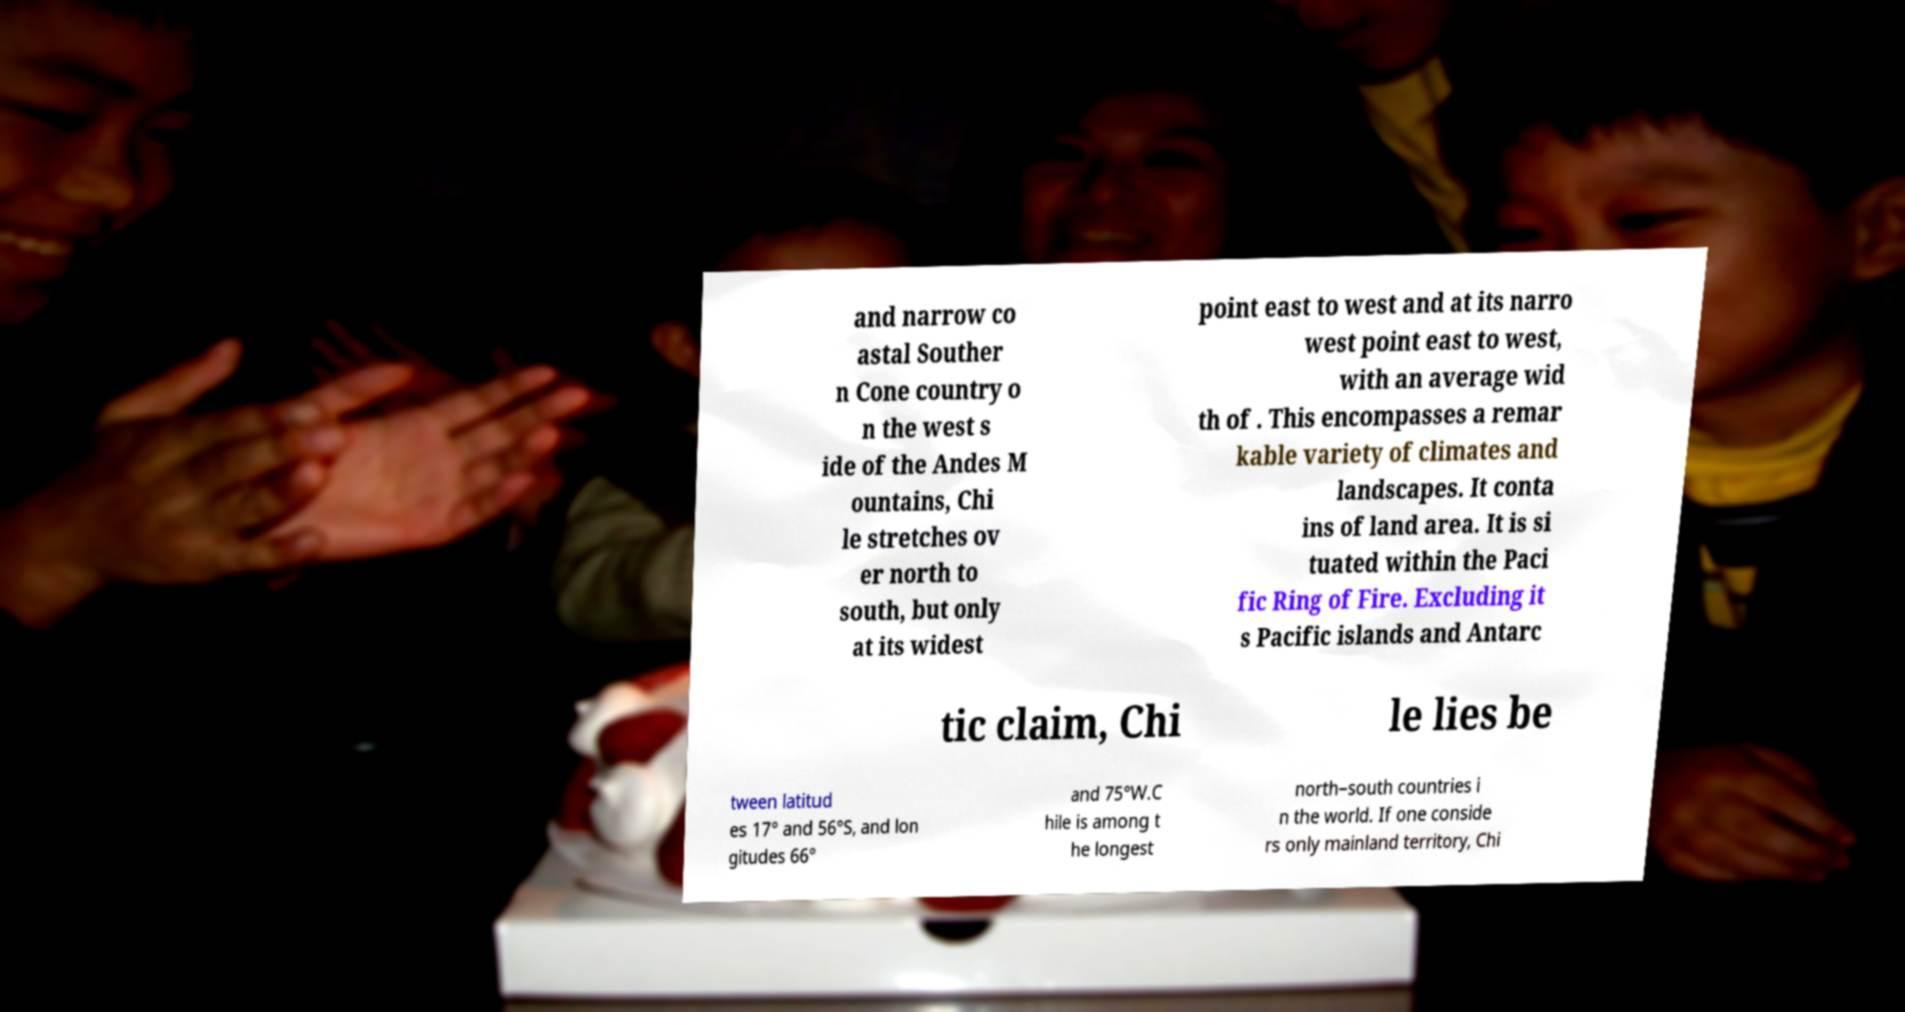For documentation purposes, I need the text within this image transcribed. Could you provide that? and narrow co astal Souther n Cone country o n the west s ide of the Andes M ountains, Chi le stretches ov er north to south, but only at its widest point east to west and at its narro west point east to west, with an average wid th of . This encompasses a remar kable variety of climates and landscapes. It conta ins of land area. It is si tuated within the Paci fic Ring of Fire. Excluding it s Pacific islands and Antarc tic claim, Chi le lies be tween latitud es 17° and 56°S, and lon gitudes 66° and 75°W.C hile is among t he longest north–south countries i n the world. If one conside rs only mainland territory, Chi 